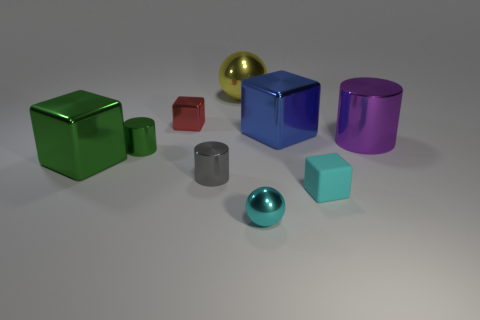Subtract 1 cubes. How many cubes are left? 3 Subtract all balls. How many objects are left? 7 Add 1 red objects. How many red objects are left? 2 Add 3 large red cubes. How many large red cubes exist? 3 Subtract 1 green blocks. How many objects are left? 8 Subtract all tiny yellow cubes. Subtract all big balls. How many objects are left? 8 